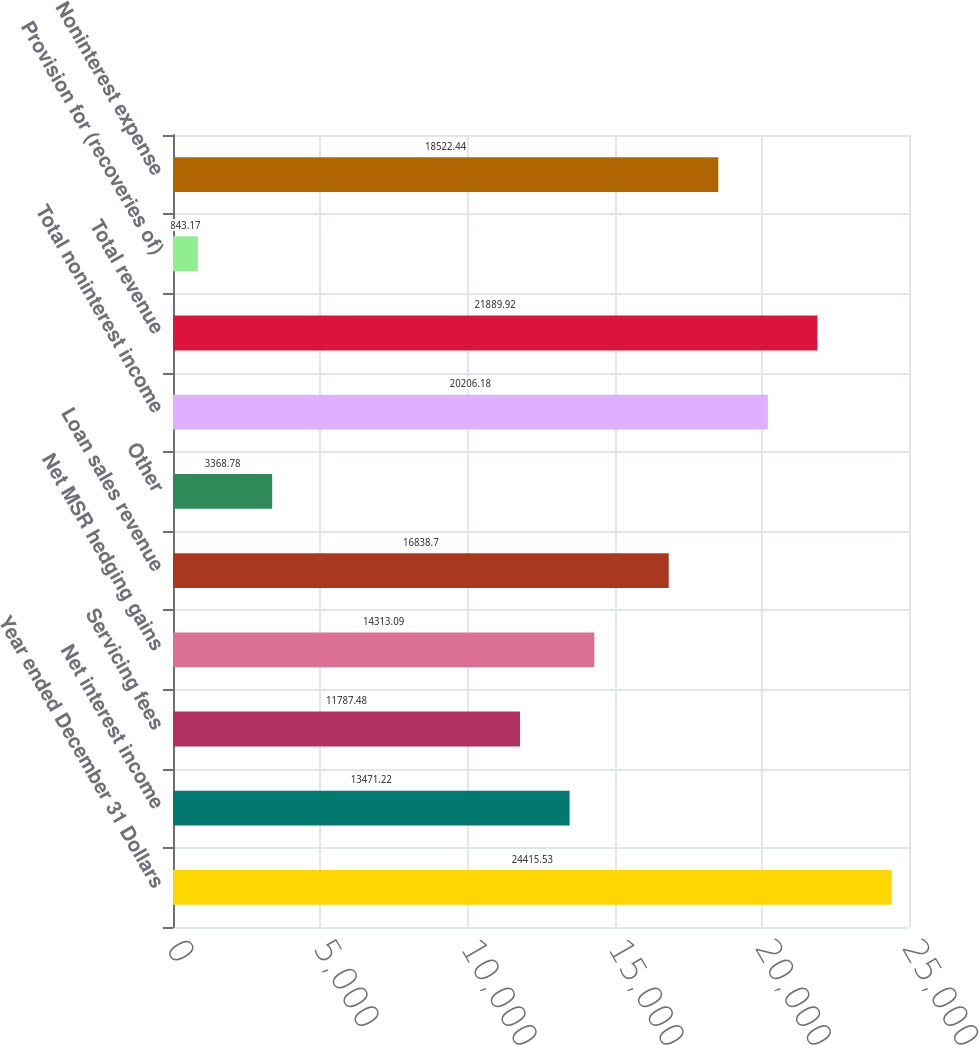<chart> <loc_0><loc_0><loc_500><loc_500><bar_chart><fcel>Year ended December 31 Dollars<fcel>Net interest income<fcel>Servicing fees<fcel>Net MSR hedging gains<fcel>Loan sales revenue<fcel>Other<fcel>Total noninterest income<fcel>Total revenue<fcel>Provision for (recoveries of)<fcel>Noninterest expense<nl><fcel>24415.5<fcel>13471.2<fcel>11787.5<fcel>14313.1<fcel>16838.7<fcel>3368.78<fcel>20206.2<fcel>21889.9<fcel>843.17<fcel>18522.4<nl></chart> 